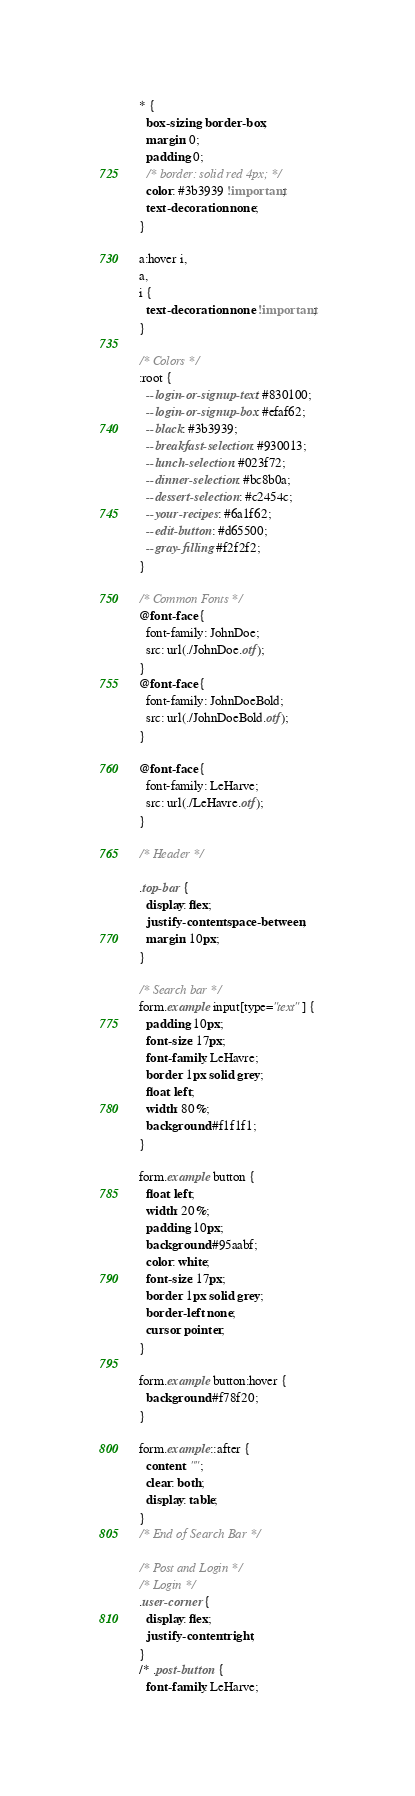Convert code to text. <code><loc_0><loc_0><loc_500><loc_500><_CSS_>* {
  box-sizing: border-box;
  margin: 0;
  padding: 0;
  /* border: solid red 4px; */
  color: #3b3939 !important;
  text-decoration: none;
}

a:hover i,
a,
i {
  text-decoration: none !important;
}

/* Colors */
:root {
  --login-or-signup-text: #830100;
  --login-or-signup-box: #efaf62;
  --black: #3b3939;
  --breakfast-selection: #930013;
  --lunch-selection: #023f72;
  --dinner-selection: #bc8b0a;
  --dessert-selection: #c2454c;
  --your-recipes: #6a1f62;
  --edit-button: #d65500;
  --gray-filling: #f2f2f2;
}

/* Common Fonts */
@font-face {
  font-family: JohnDoe;
  src: url(./JohnDoe.otf);
}
@font-face {
  font-family: JohnDoeBold;
  src: url(./JohnDoeBold.otf);
}

@font-face {
  font-family: LeHarve;
  src: url(./LeHavre.otf);
}

/* Header */

.top-bar {
  display: flex;
  justify-content: space-between;
  margin: 10px;
}

/* Search bar */
form.example input[type="text"] {
  padding: 10px;
  font-size: 17px;
  font-family: LeHavre;
  border: 1px solid grey;
  float: left;
  width: 80%;
  background: #f1f1f1;
}

form.example button {
  float: left;
  width: 20%;
  padding: 10px;
  background: #95aabf;
  color: white;
  font-size: 17px;
  border: 1px solid grey;
  border-left: none;
  cursor: pointer;
}

form.example button:hover {
  background: #f78f20;
}

form.example::after {
  content: "";
  clear: both;
  display: table;
}
/* End of Search Bar */

/* Post and Login */
/* Login */
.user-corner {
  display: flex;
  justify-content: right;
}
/* .post-button {
  font-family: LeHarve;</code> 